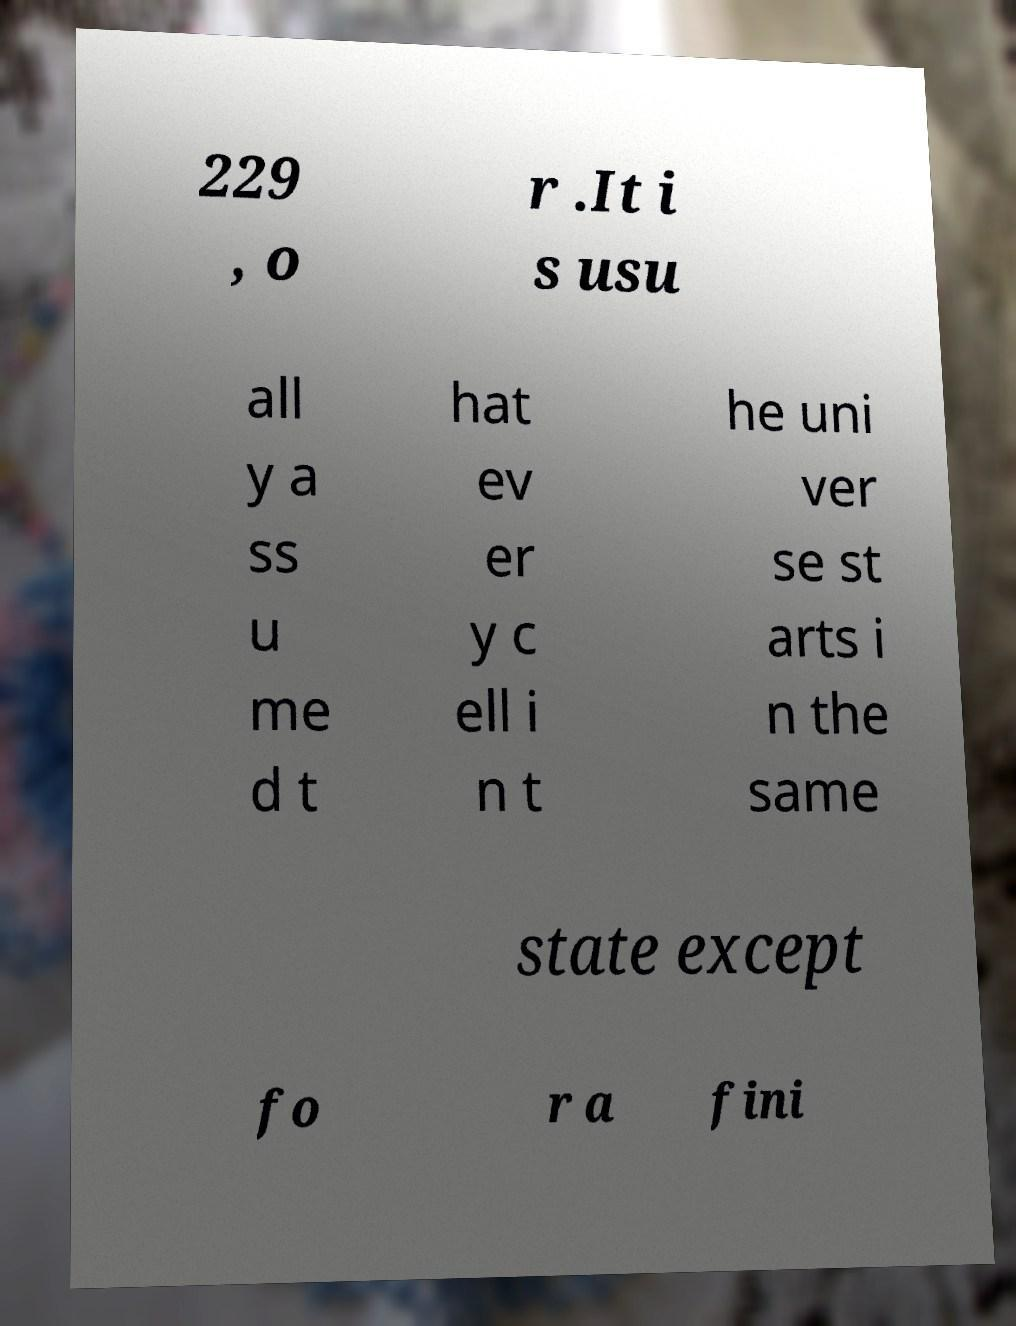What messages or text are displayed in this image? I need them in a readable, typed format. 229 , o r .It i s usu all y a ss u me d t hat ev er y c ell i n t he uni ver se st arts i n the same state except fo r a fini 